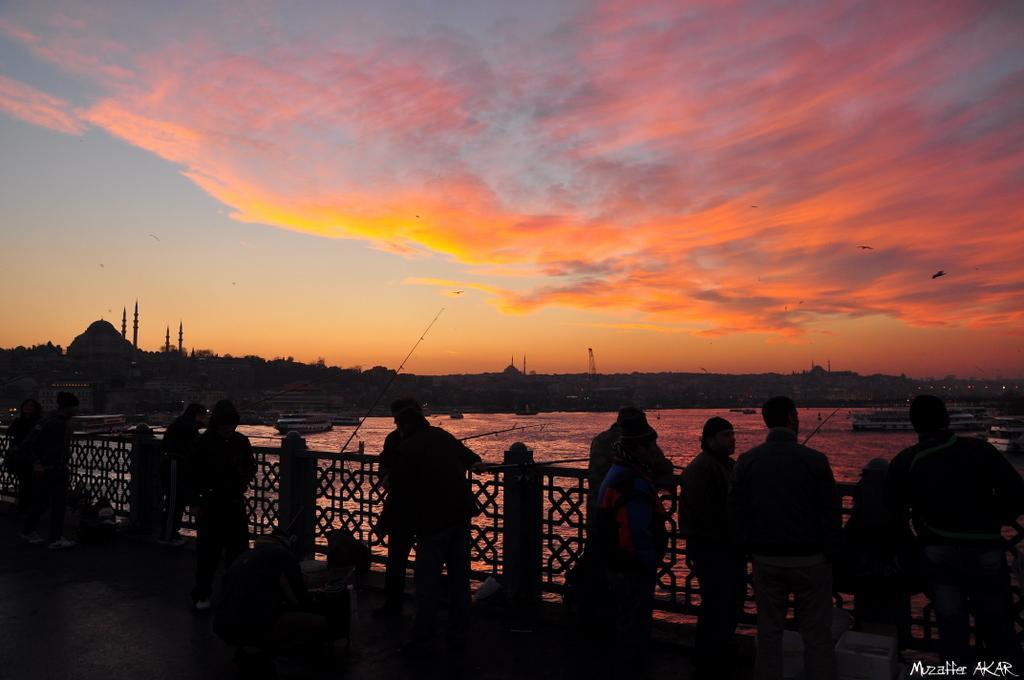Please provide a concise description of this image. There are persons standing on a floor in front of a fencing. In the right bottom corner, there is a watermark. In the background, there are boats on the water, there are trees, buildings, and there are clouds in the blue sky. 